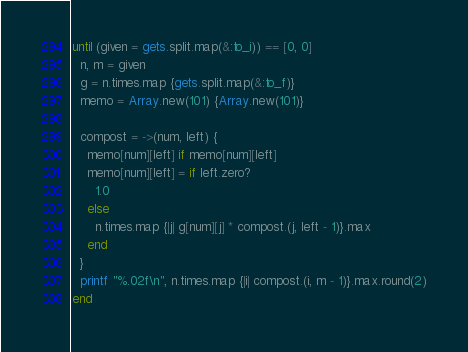Convert code to text. <code><loc_0><loc_0><loc_500><loc_500><_Ruby_>until (given = gets.split.map(&:to_i)) == [0, 0]
  n, m = given
  g = n.times.map {gets.split.map(&:to_f)}
  memo = Array.new(101) {Array.new(101)}
  
  compost = ->(num, left) {
    memo[num][left] if memo[num][left]
    memo[num][left] = if left.zero?
      1.0
    else
      n.times.map {|j| g[num][j] * compost.(j, left - 1)}.max
    end
  }
  printf "%.02f\n", n.times.map {|i| compost.(i, m - 1)}.max.round(2)
end
</code> 